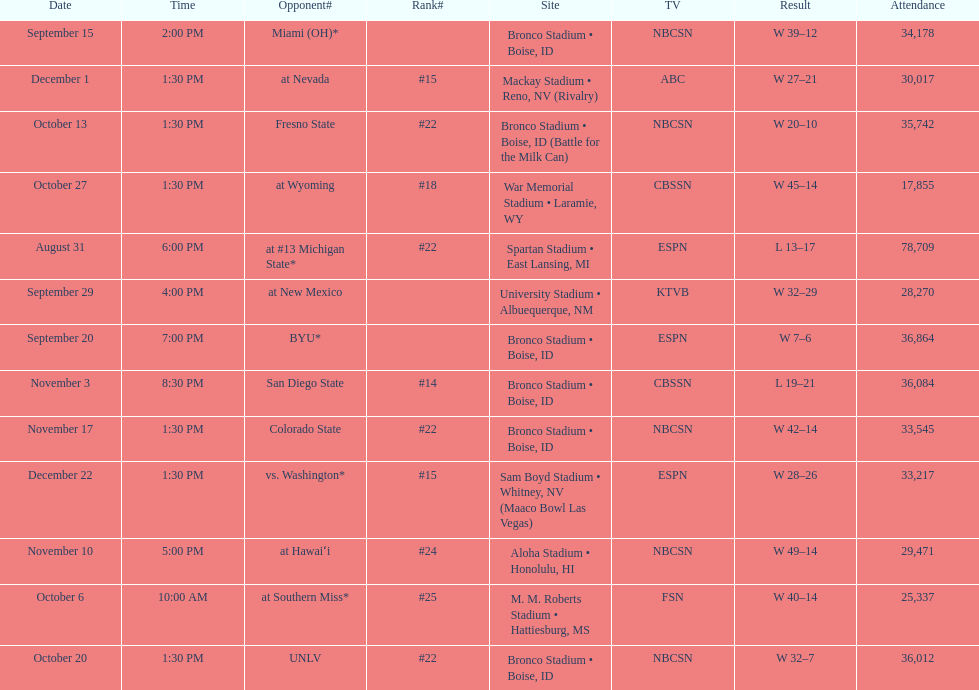What rank was boise state after november 10th? #22. 